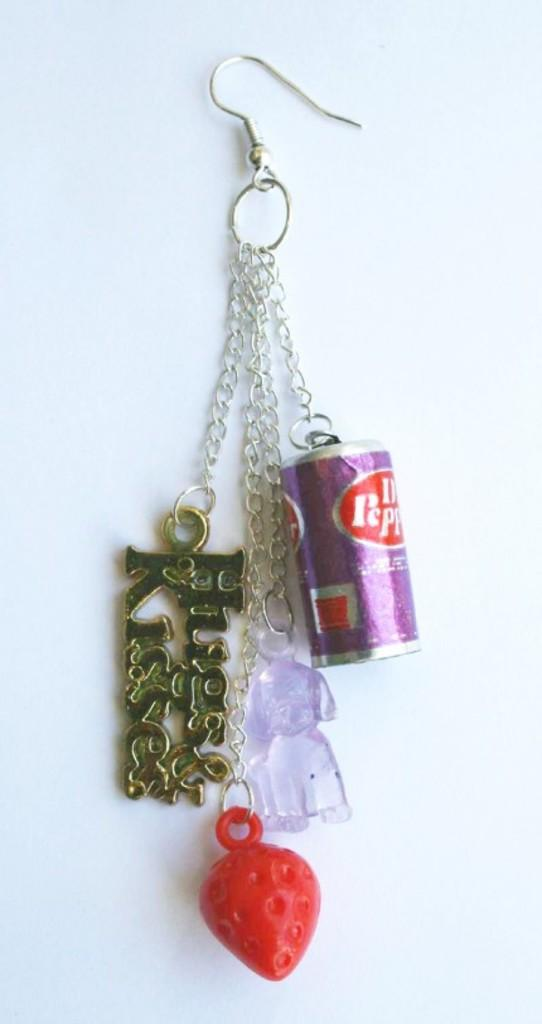What is the primary feature of the image? The primary feature of the image is objects attached to a hook. Can you describe the objects that are attached to the hook? Unfortunately, the specific objects cannot be identified from the provided facts. What might be the purpose of attaching objects to a hook? The purpose of attaching objects to a hook could be for storage, display, or organization. Is there a scarecrow present in the image? There is no mention of a scarecrow in the provided facts, so it cannot be determined if one is present in the image. 